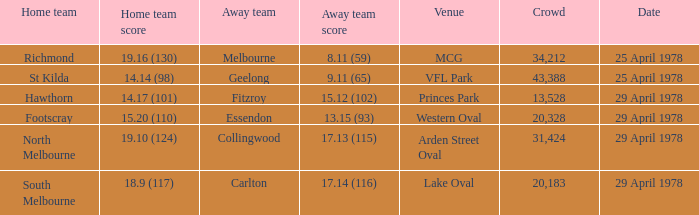What was the away team that played at Princes Park? Fitzroy. 